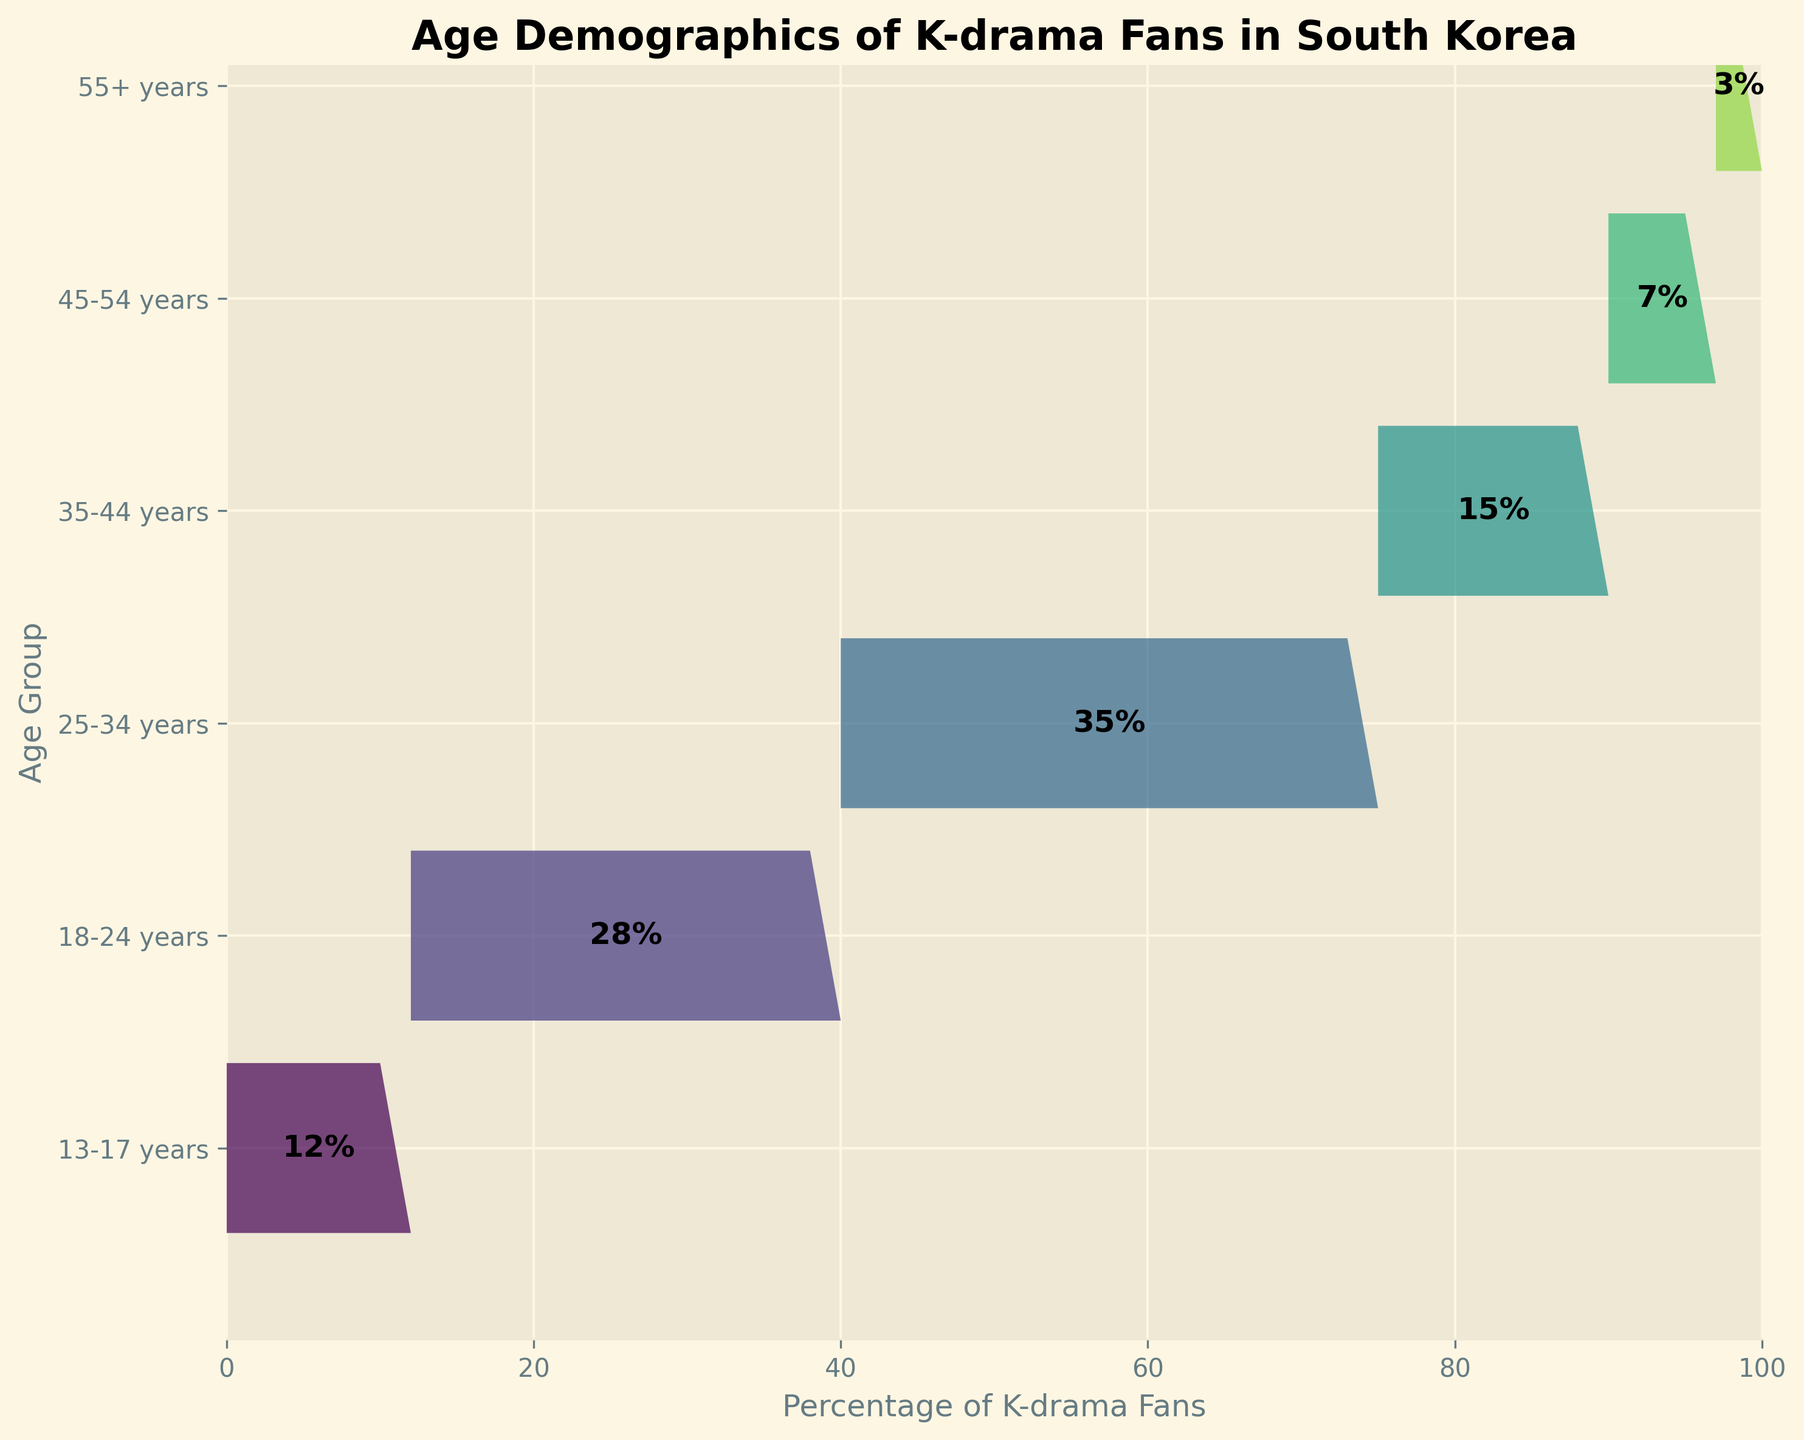Which age group has the highest percentage of K-drama fans? By examining the lengths of the bars in the funnel chart, the longest bar corresponds to the age group of 25-34 years. The percentage is displayed as 35%.
Answer: 25-34 years What's the percentage of K-drama fans in the 18-24 years age group? Look at the bar labeled 18-24 years. The percentage labeled in the center of this bar is 28%.
Answer: 28% How does the percentage of K-drama fans in the 35-44 years age group compare to the 45-54 years age group? Locate the bars for both age groups. The bar for 35-44 years shows 15%, and the bar for 45-54 years shows 7%. Comparing these, the 35-44 group has a higher percentage.
Answer: 35-44 years has a higher percentage What's the total percentage of K-drama fans below 25 years? Add the percentages of the bars for the 13-17 years (12%) and 18-24 years (28%) age groups. 12 + 28 = 40%.
Answer: 40% What proportion of K-drama fans are in the 55+ years age group? Check the bar for the 55+ years age group, which shows 3%. Since the total of all percentages must equal 100%, the proportion is 3%.
Answer: 3% Which age group has the least percentage of K-drama fans? The smallest bar in the funnel chart represents the 55+ years age group, with a percentage of 3%.
Answer: 55+ years How many age groups have more than 10% of K-drama fans? Identify the bars with percentages higher than 10%: 13-17 years (12%), 18-24 years (28%), 25-34 years (35%), and 35-44 years (15%). There are 4 such age groups.
Answer: 4 What is the cumulative percentage of K-drama fans for the age groups from 25-34 years and 35-44 years? Add the percentages for the 25-34 years (35%) and 35-44 years (15%) age groups. 35 + 15 = 50%.
Answer: 50% 